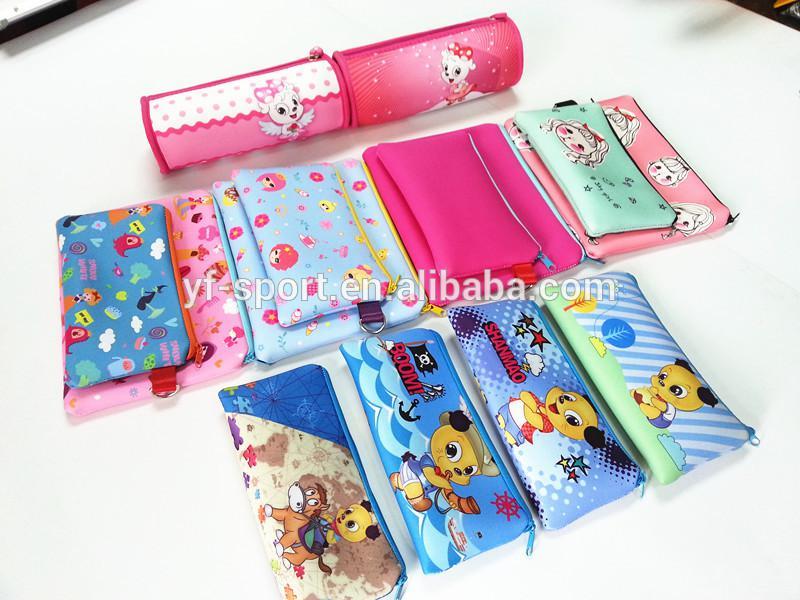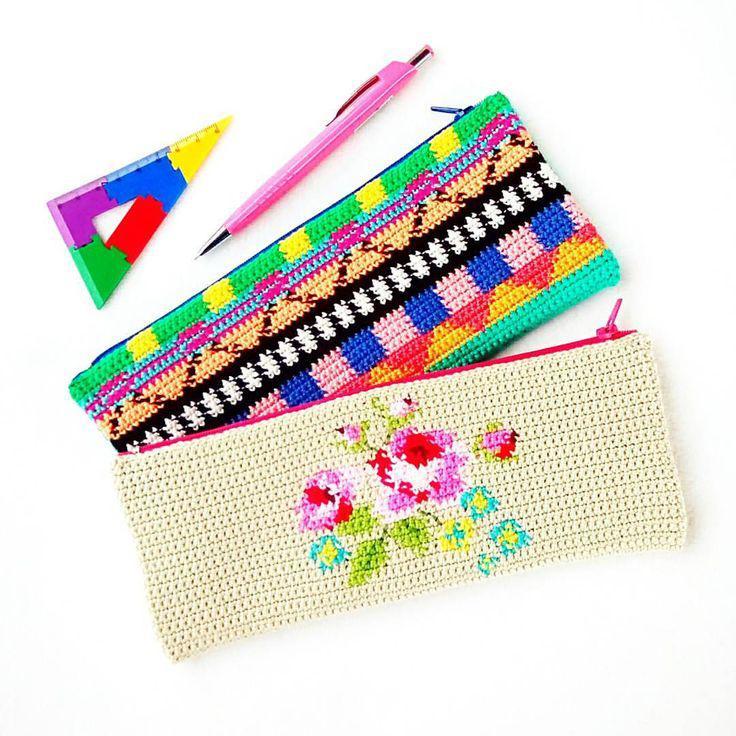The first image is the image on the left, the second image is the image on the right. Analyze the images presented: Is the assertion "An image includes a flat case with a zig-zag pattern and yellow pencils sticking out of its front pocket." valid? Answer yes or no. No. The first image is the image on the left, the second image is the image on the right. Examine the images to the left and right. Is the description "In one of the images, three pencils are sticking out of the front pocket on the pencil case." accurate? Answer yes or no. No. 